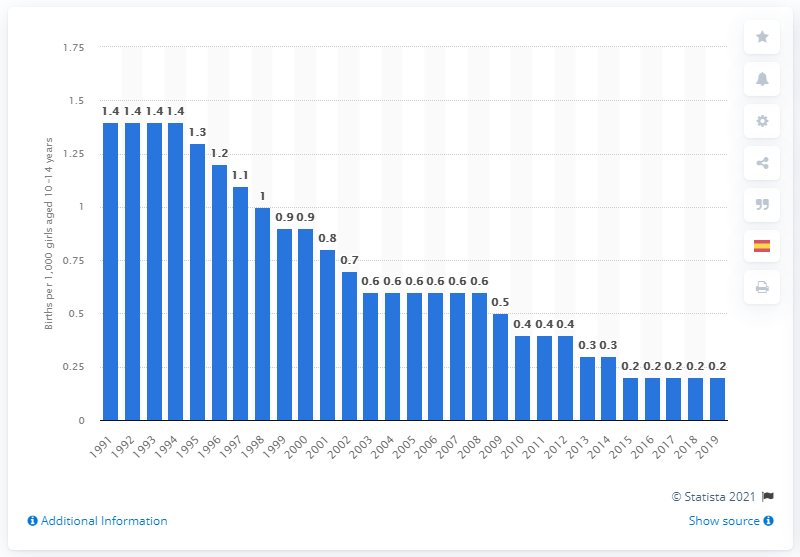Outline some significant characteristics in this image. In 1991, the birth rate for girls aged 10 to 14 years in the United States was 1.4. 